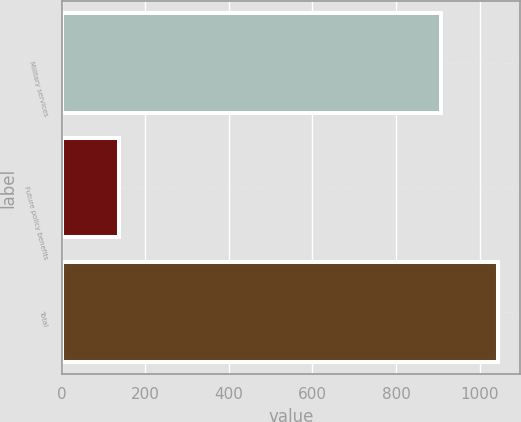Convert chart. <chart><loc_0><loc_0><loc_500><loc_500><bar_chart><fcel>Military services<fcel>Future policy benefits<fcel>Total<nl><fcel>908<fcel>136<fcel>1044<nl></chart> 